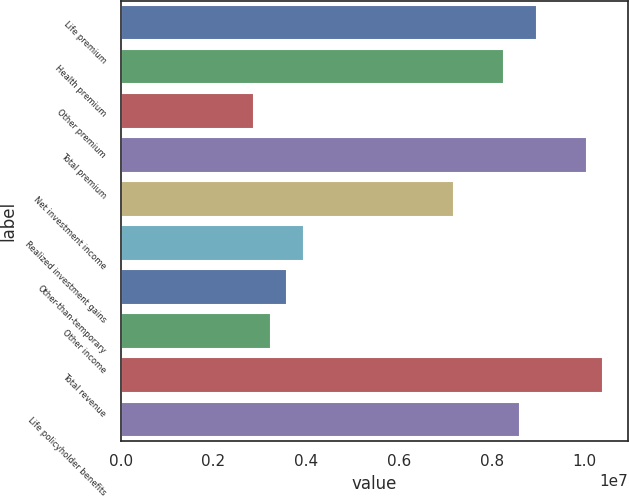<chart> <loc_0><loc_0><loc_500><loc_500><bar_chart><fcel>Life premium<fcel>Health premium<fcel>Other premium<fcel>Total premium<fcel>Net investment income<fcel>Realized investment gains<fcel>Other-than-temporary<fcel>Other income<fcel>Total revenue<fcel>Life policyholder benefits<nl><fcel>8.97379e+06<fcel>8.25589e+06<fcel>2.87161e+06<fcel>1.00506e+07<fcel>7.17903e+06<fcel>3.94847e+06<fcel>3.58952e+06<fcel>3.23056e+06<fcel>1.04096e+07<fcel>8.61484e+06<nl></chart> 